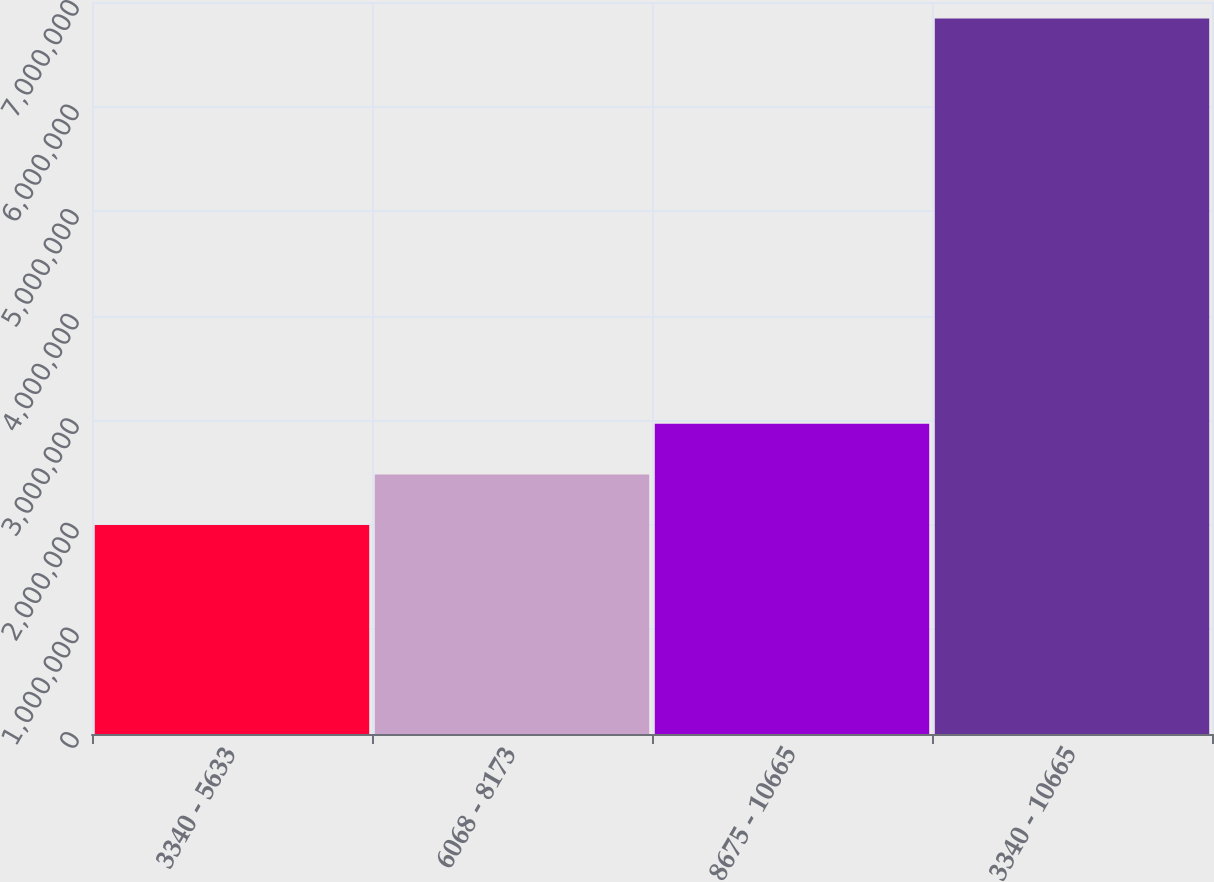<chart> <loc_0><loc_0><loc_500><loc_500><bar_chart><fcel>3340 - 5633<fcel>6068 - 8173<fcel>8675 - 10665<fcel>3340 - 10665<nl><fcel>1.99806e+06<fcel>2.48251e+06<fcel>2.96696e+06<fcel>6.84256e+06<nl></chart> 